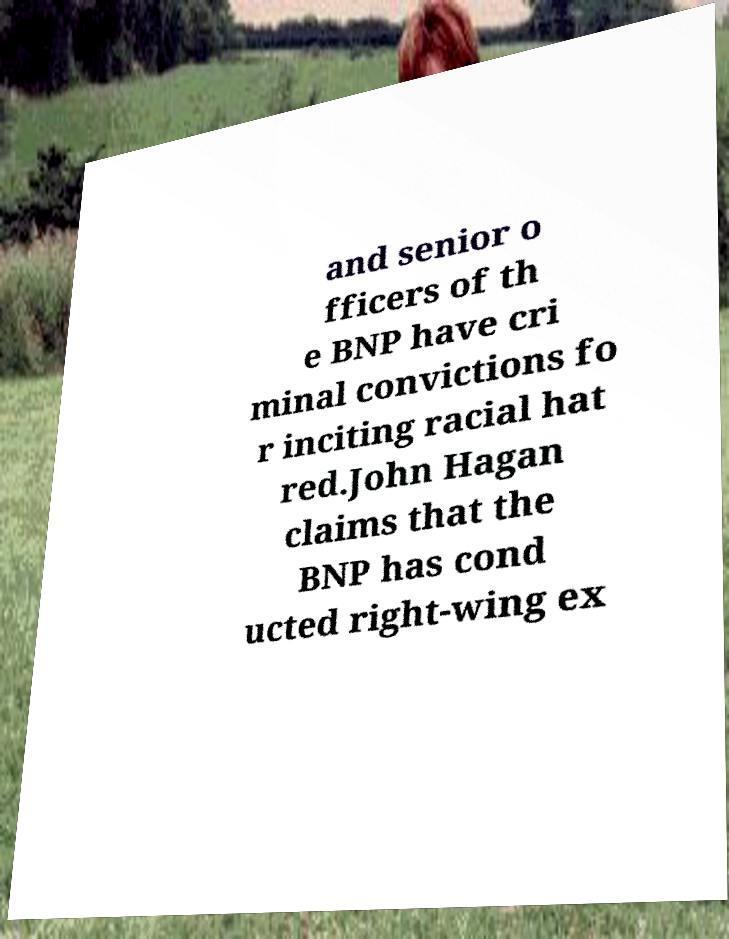Could you extract and type out the text from this image? and senior o fficers of th e BNP have cri minal convictions fo r inciting racial hat red.John Hagan claims that the BNP has cond ucted right-wing ex 